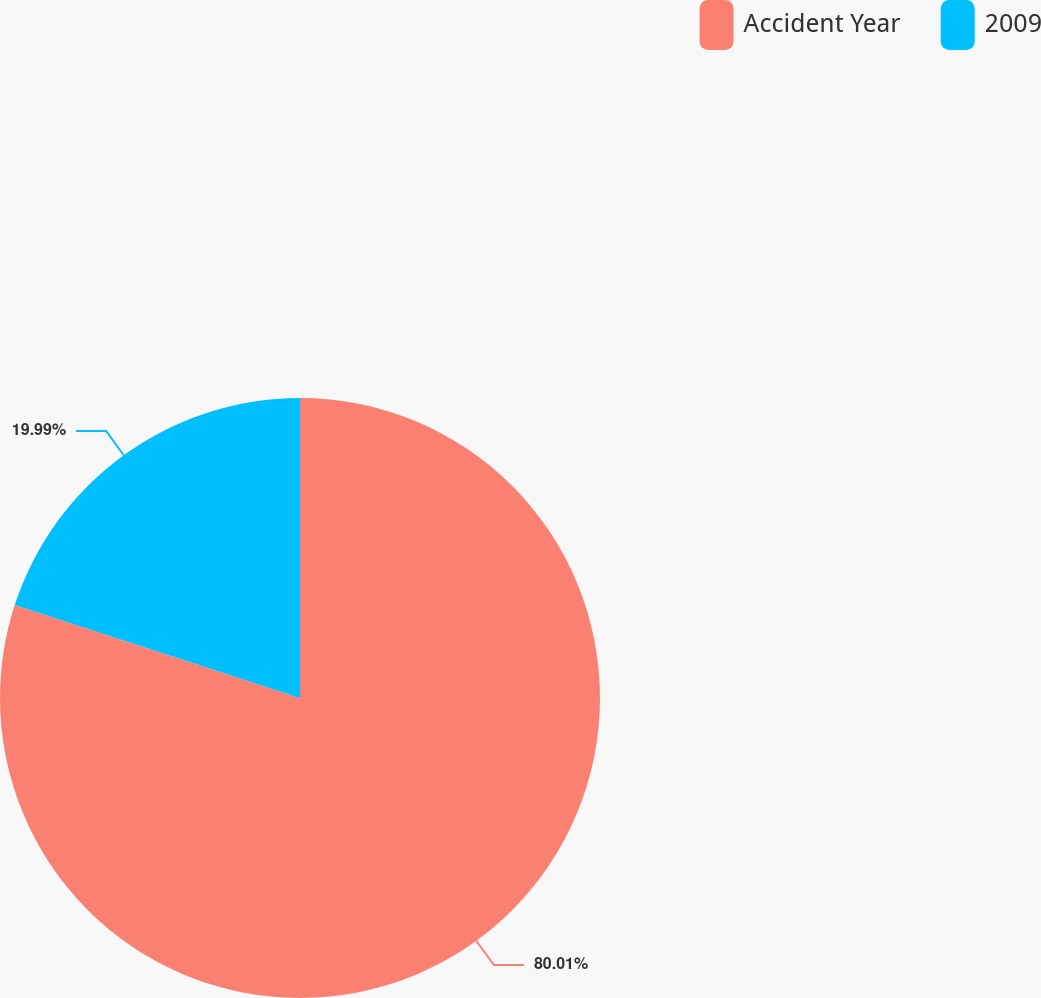Convert chart. <chart><loc_0><loc_0><loc_500><loc_500><pie_chart><fcel>Accident Year<fcel>2009<nl><fcel>80.01%<fcel>19.99%<nl></chart> 